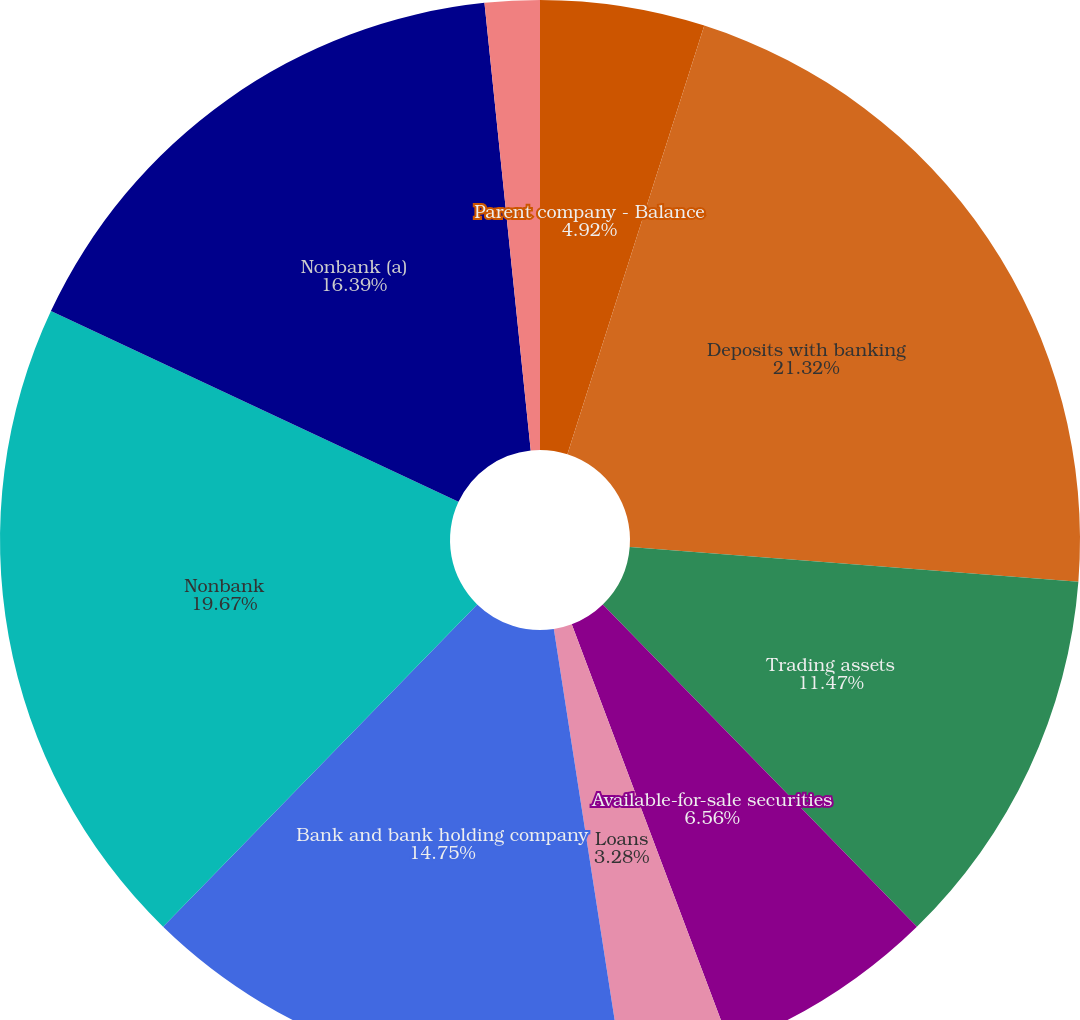Convert chart. <chart><loc_0><loc_0><loc_500><loc_500><pie_chart><fcel>Parent company - Balance<fcel>Cash and due from banks<fcel>Deposits with banking<fcel>Trading assets<fcel>Available-for-sale securities<fcel>Loans<fcel>Bank and bank holding company<fcel>Nonbank<fcel>Nonbank (a)<fcel>Goodwill and other intangibles<nl><fcel>4.92%<fcel>0.0%<fcel>21.31%<fcel>11.47%<fcel>6.56%<fcel>3.28%<fcel>14.75%<fcel>19.67%<fcel>16.39%<fcel>1.64%<nl></chart> 